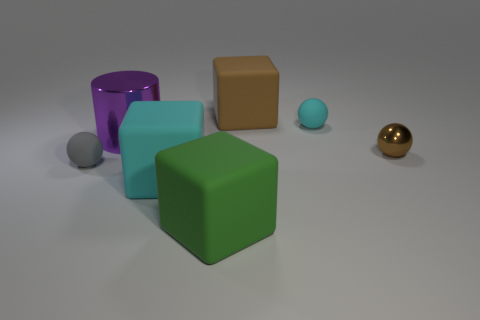Are there any green matte objects that have the same shape as the gray matte thing?
Keep it short and to the point. No. What number of objects are big brown objects that are to the right of the gray object or big gray cylinders?
Give a very brief answer. 1. Are there more purple rubber things than large cubes?
Make the answer very short. No. Is there another green matte cube of the same size as the green block?
Keep it short and to the point. No. How many objects are either spheres behind the metal ball or cyan objects that are in front of the brown metal thing?
Provide a short and direct response. 2. What is the color of the tiny object left of the cyan thing that is behind the metallic cylinder?
Keep it short and to the point. Gray. What color is the small object that is the same material as the gray ball?
Give a very brief answer. Cyan. How many big things have the same color as the tiny metallic sphere?
Provide a short and direct response. 1. What number of objects are either red matte balls or blocks?
Ensure brevity in your answer.  3. There is a cyan rubber object that is the same size as the purple thing; what shape is it?
Provide a short and direct response. Cube. 